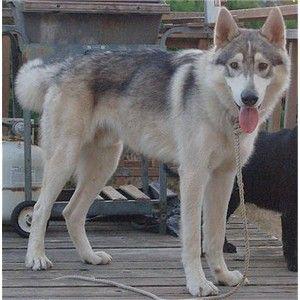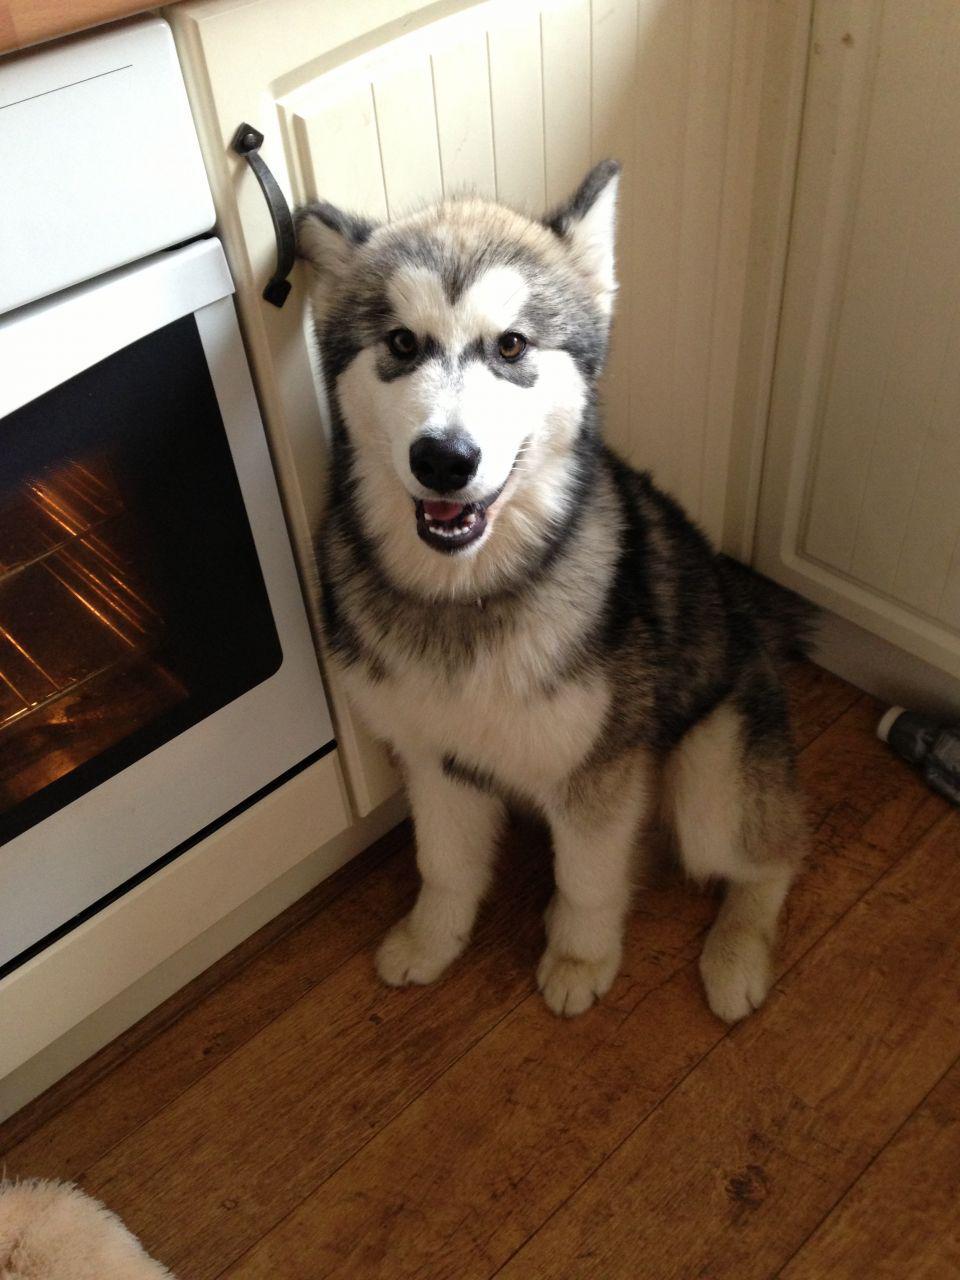The first image is the image on the left, the second image is the image on the right. Analyze the images presented: Is the assertion "The dog in one of the images is standing on the wood planks of a deck outside." valid? Answer yes or no. Yes. The first image is the image on the left, the second image is the image on the right. Analyze the images presented: Is the assertion "The right image shows a husky standing in profile with its tail curled inward, and the left image shows a dog on a rope in a standing pose in front of an outdoor 'wall'." valid? Answer yes or no. No. 